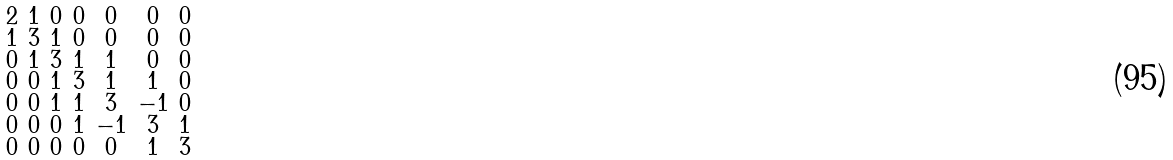<formula> <loc_0><loc_0><loc_500><loc_500>\begin{smallmatrix} 2 & 1 & 0 & 0 & 0 & 0 & 0 \\ 1 & 3 & 1 & 0 & 0 & 0 & 0 \\ 0 & 1 & 3 & 1 & 1 & 0 & 0 \\ 0 & 0 & 1 & 3 & 1 & 1 & 0 \\ 0 & 0 & 1 & 1 & 3 & - 1 & 0 \\ 0 & 0 & 0 & 1 & - 1 & 3 & 1 \\ 0 & 0 & 0 & 0 & 0 & 1 & 3 \end{smallmatrix}</formula> 